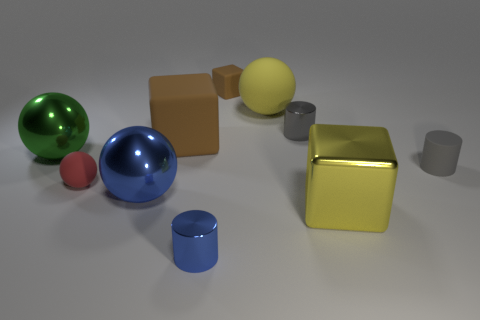Subtract all green shiny spheres. How many spheres are left? 3 Subtract all gray spheres. Subtract all cyan blocks. How many spheres are left? 4 Subtract all cylinders. How many objects are left? 7 Subtract all large yellow spheres. Subtract all red spheres. How many objects are left? 8 Add 7 large balls. How many large balls are left? 10 Add 1 big blue metal things. How many big blue metal things exist? 2 Subtract 1 green spheres. How many objects are left? 9 